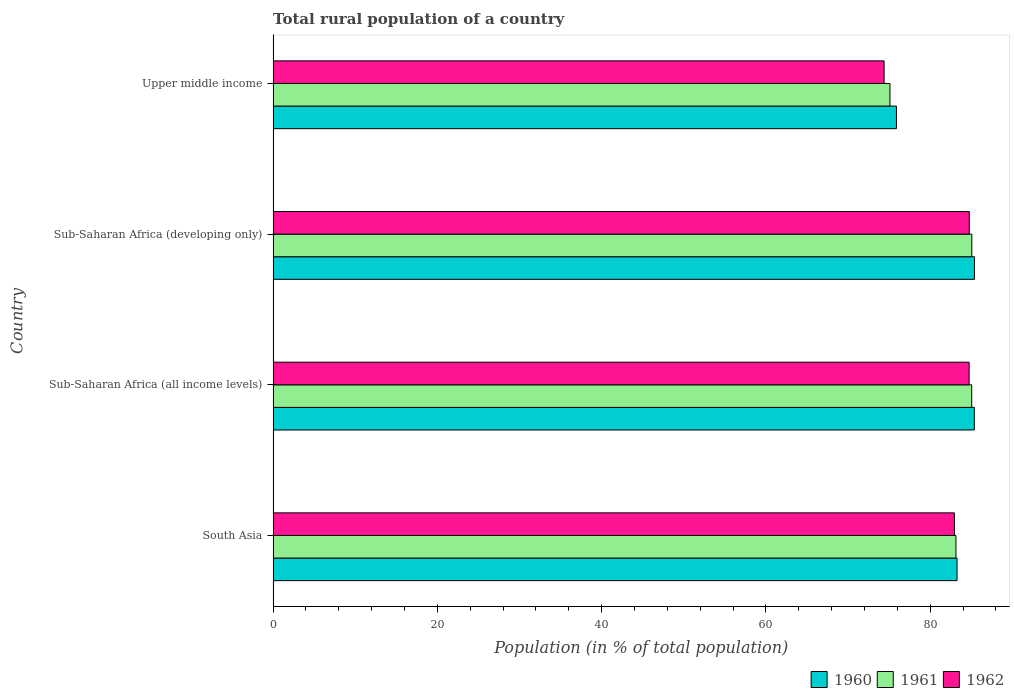How many groups of bars are there?
Offer a terse response. 4. Are the number of bars per tick equal to the number of legend labels?
Give a very brief answer. Yes. How many bars are there on the 1st tick from the top?
Your response must be concise. 3. What is the label of the 3rd group of bars from the top?
Give a very brief answer. Sub-Saharan Africa (all income levels). In how many cases, is the number of bars for a given country not equal to the number of legend labels?
Offer a terse response. 0. What is the rural population in 1961 in Upper middle income?
Offer a very short reply. 75.1. Across all countries, what is the maximum rural population in 1962?
Provide a short and direct response. 84.75. Across all countries, what is the minimum rural population in 1961?
Offer a terse response. 75.1. In which country was the rural population in 1961 maximum?
Offer a very short reply. Sub-Saharan Africa (developing only). In which country was the rural population in 1961 minimum?
Provide a short and direct response. Upper middle income. What is the total rural population in 1961 in the graph?
Offer a terse response. 328.35. What is the difference between the rural population in 1962 in Sub-Saharan Africa (all income levels) and that in Sub-Saharan Africa (developing only)?
Your answer should be compact. -0.01. What is the difference between the rural population in 1962 in Upper middle income and the rural population in 1960 in South Asia?
Offer a very short reply. -8.88. What is the average rural population in 1960 per country?
Your answer should be very brief. 82.48. What is the difference between the rural population in 1961 and rural population in 1960 in Sub-Saharan Africa (developing only)?
Your answer should be compact. -0.32. In how many countries, is the rural population in 1962 greater than 72 %?
Provide a short and direct response. 4. What is the ratio of the rural population in 1961 in South Asia to that in Sub-Saharan Africa (all income levels)?
Make the answer very short. 0.98. Is the rural population in 1962 in Sub-Saharan Africa (developing only) less than that in Upper middle income?
Provide a succinct answer. No. What is the difference between the highest and the second highest rural population in 1962?
Make the answer very short. 0.01. What is the difference between the highest and the lowest rural population in 1962?
Ensure brevity in your answer.  10.37. In how many countries, is the rural population in 1960 greater than the average rural population in 1960 taken over all countries?
Ensure brevity in your answer.  3. What does the 2nd bar from the top in Sub-Saharan Africa (all income levels) represents?
Your answer should be very brief. 1961. Is it the case that in every country, the sum of the rural population in 1961 and rural population in 1960 is greater than the rural population in 1962?
Your answer should be compact. Yes. What is the difference between two consecutive major ticks on the X-axis?
Ensure brevity in your answer.  20. Are the values on the major ticks of X-axis written in scientific E-notation?
Keep it short and to the point. No. Does the graph contain any zero values?
Make the answer very short. No. Does the graph contain grids?
Give a very brief answer. No. How many legend labels are there?
Ensure brevity in your answer.  3. What is the title of the graph?
Ensure brevity in your answer.  Total rural population of a country. Does "1978" appear as one of the legend labels in the graph?
Give a very brief answer. No. What is the label or title of the X-axis?
Give a very brief answer. Population (in % of total population). What is the label or title of the Y-axis?
Provide a short and direct response. Country. What is the Population (in % of total population) of 1960 in South Asia?
Your response must be concise. 83.26. What is the Population (in % of total population) of 1961 in South Asia?
Your answer should be very brief. 83.13. What is the Population (in % of total population) in 1962 in South Asia?
Ensure brevity in your answer.  82.95. What is the Population (in % of total population) in 1960 in Sub-Saharan Africa (all income levels)?
Offer a terse response. 85.37. What is the Population (in % of total population) in 1961 in Sub-Saharan Africa (all income levels)?
Your answer should be compact. 85.05. What is the Population (in % of total population) of 1962 in Sub-Saharan Africa (all income levels)?
Offer a very short reply. 84.74. What is the Population (in % of total population) in 1960 in Sub-Saharan Africa (developing only)?
Offer a very short reply. 85.38. What is the Population (in % of total population) in 1961 in Sub-Saharan Africa (developing only)?
Your response must be concise. 85.07. What is the Population (in % of total population) in 1962 in Sub-Saharan Africa (developing only)?
Offer a very short reply. 84.75. What is the Population (in % of total population) in 1960 in Upper middle income?
Your response must be concise. 75.89. What is the Population (in % of total population) in 1961 in Upper middle income?
Your answer should be compact. 75.1. What is the Population (in % of total population) in 1962 in Upper middle income?
Provide a short and direct response. 74.39. Across all countries, what is the maximum Population (in % of total population) in 1960?
Keep it short and to the point. 85.38. Across all countries, what is the maximum Population (in % of total population) of 1961?
Your answer should be compact. 85.07. Across all countries, what is the maximum Population (in % of total population) of 1962?
Your answer should be compact. 84.75. Across all countries, what is the minimum Population (in % of total population) of 1960?
Your answer should be compact. 75.89. Across all countries, what is the minimum Population (in % of total population) of 1961?
Offer a very short reply. 75.1. Across all countries, what is the minimum Population (in % of total population) of 1962?
Give a very brief answer. 74.39. What is the total Population (in % of total population) of 1960 in the graph?
Offer a very short reply. 329.91. What is the total Population (in % of total population) in 1961 in the graph?
Provide a short and direct response. 328.35. What is the total Population (in % of total population) of 1962 in the graph?
Offer a very short reply. 326.83. What is the difference between the Population (in % of total population) in 1960 in South Asia and that in Sub-Saharan Africa (all income levels)?
Offer a very short reply. -2.1. What is the difference between the Population (in % of total population) in 1961 in South Asia and that in Sub-Saharan Africa (all income levels)?
Your answer should be compact. -1.92. What is the difference between the Population (in % of total population) in 1962 in South Asia and that in Sub-Saharan Africa (all income levels)?
Your answer should be very brief. -1.79. What is the difference between the Population (in % of total population) of 1960 in South Asia and that in Sub-Saharan Africa (developing only)?
Your answer should be compact. -2.12. What is the difference between the Population (in % of total population) of 1961 in South Asia and that in Sub-Saharan Africa (developing only)?
Make the answer very short. -1.93. What is the difference between the Population (in % of total population) of 1962 in South Asia and that in Sub-Saharan Africa (developing only)?
Provide a short and direct response. -1.81. What is the difference between the Population (in % of total population) in 1960 in South Asia and that in Upper middle income?
Make the answer very short. 7.37. What is the difference between the Population (in % of total population) of 1961 in South Asia and that in Upper middle income?
Provide a succinct answer. 8.03. What is the difference between the Population (in % of total population) in 1962 in South Asia and that in Upper middle income?
Provide a succinct answer. 8.56. What is the difference between the Population (in % of total population) in 1960 in Sub-Saharan Africa (all income levels) and that in Sub-Saharan Africa (developing only)?
Keep it short and to the point. -0.01. What is the difference between the Population (in % of total population) of 1961 in Sub-Saharan Africa (all income levels) and that in Sub-Saharan Africa (developing only)?
Your response must be concise. -0.01. What is the difference between the Population (in % of total population) of 1962 in Sub-Saharan Africa (all income levels) and that in Sub-Saharan Africa (developing only)?
Ensure brevity in your answer.  -0.01. What is the difference between the Population (in % of total population) of 1960 in Sub-Saharan Africa (all income levels) and that in Upper middle income?
Make the answer very short. 9.48. What is the difference between the Population (in % of total population) in 1961 in Sub-Saharan Africa (all income levels) and that in Upper middle income?
Keep it short and to the point. 9.95. What is the difference between the Population (in % of total population) in 1962 in Sub-Saharan Africa (all income levels) and that in Upper middle income?
Give a very brief answer. 10.35. What is the difference between the Population (in % of total population) of 1960 in Sub-Saharan Africa (developing only) and that in Upper middle income?
Give a very brief answer. 9.49. What is the difference between the Population (in % of total population) in 1961 in Sub-Saharan Africa (developing only) and that in Upper middle income?
Offer a very short reply. 9.97. What is the difference between the Population (in % of total population) of 1962 in Sub-Saharan Africa (developing only) and that in Upper middle income?
Offer a terse response. 10.37. What is the difference between the Population (in % of total population) of 1960 in South Asia and the Population (in % of total population) of 1961 in Sub-Saharan Africa (all income levels)?
Give a very brief answer. -1.79. What is the difference between the Population (in % of total population) of 1960 in South Asia and the Population (in % of total population) of 1962 in Sub-Saharan Africa (all income levels)?
Keep it short and to the point. -1.48. What is the difference between the Population (in % of total population) of 1961 in South Asia and the Population (in % of total population) of 1962 in Sub-Saharan Africa (all income levels)?
Give a very brief answer. -1.61. What is the difference between the Population (in % of total population) of 1960 in South Asia and the Population (in % of total population) of 1961 in Sub-Saharan Africa (developing only)?
Your answer should be compact. -1.8. What is the difference between the Population (in % of total population) of 1960 in South Asia and the Population (in % of total population) of 1962 in Sub-Saharan Africa (developing only)?
Make the answer very short. -1.49. What is the difference between the Population (in % of total population) of 1961 in South Asia and the Population (in % of total population) of 1962 in Sub-Saharan Africa (developing only)?
Provide a short and direct response. -1.62. What is the difference between the Population (in % of total population) in 1960 in South Asia and the Population (in % of total population) in 1961 in Upper middle income?
Provide a succinct answer. 8.16. What is the difference between the Population (in % of total population) in 1960 in South Asia and the Population (in % of total population) in 1962 in Upper middle income?
Give a very brief answer. 8.88. What is the difference between the Population (in % of total population) in 1961 in South Asia and the Population (in % of total population) in 1962 in Upper middle income?
Offer a terse response. 8.75. What is the difference between the Population (in % of total population) of 1960 in Sub-Saharan Africa (all income levels) and the Population (in % of total population) of 1961 in Sub-Saharan Africa (developing only)?
Make the answer very short. 0.3. What is the difference between the Population (in % of total population) of 1960 in Sub-Saharan Africa (all income levels) and the Population (in % of total population) of 1962 in Sub-Saharan Africa (developing only)?
Offer a terse response. 0.61. What is the difference between the Population (in % of total population) of 1961 in Sub-Saharan Africa (all income levels) and the Population (in % of total population) of 1962 in Sub-Saharan Africa (developing only)?
Your answer should be very brief. 0.3. What is the difference between the Population (in % of total population) in 1960 in Sub-Saharan Africa (all income levels) and the Population (in % of total population) in 1961 in Upper middle income?
Keep it short and to the point. 10.27. What is the difference between the Population (in % of total population) of 1960 in Sub-Saharan Africa (all income levels) and the Population (in % of total population) of 1962 in Upper middle income?
Make the answer very short. 10.98. What is the difference between the Population (in % of total population) of 1961 in Sub-Saharan Africa (all income levels) and the Population (in % of total population) of 1962 in Upper middle income?
Keep it short and to the point. 10.67. What is the difference between the Population (in % of total population) in 1960 in Sub-Saharan Africa (developing only) and the Population (in % of total population) in 1961 in Upper middle income?
Provide a short and direct response. 10.28. What is the difference between the Population (in % of total population) of 1960 in Sub-Saharan Africa (developing only) and the Population (in % of total population) of 1962 in Upper middle income?
Offer a terse response. 11. What is the difference between the Population (in % of total population) of 1961 in Sub-Saharan Africa (developing only) and the Population (in % of total population) of 1962 in Upper middle income?
Offer a very short reply. 10.68. What is the average Population (in % of total population) of 1960 per country?
Provide a succinct answer. 82.48. What is the average Population (in % of total population) in 1961 per country?
Your response must be concise. 82.09. What is the average Population (in % of total population) in 1962 per country?
Offer a terse response. 81.71. What is the difference between the Population (in % of total population) in 1960 and Population (in % of total population) in 1961 in South Asia?
Your answer should be very brief. 0.13. What is the difference between the Population (in % of total population) of 1960 and Population (in % of total population) of 1962 in South Asia?
Provide a succinct answer. 0.32. What is the difference between the Population (in % of total population) in 1961 and Population (in % of total population) in 1962 in South Asia?
Your response must be concise. 0.19. What is the difference between the Population (in % of total population) of 1960 and Population (in % of total population) of 1961 in Sub-Saharan Africa (all income levels)?
Your answer should be very brief. 0.32. What is the difference between the Population (in % of total population) in 1960 and Population (in % of total population) in 1962 in Sub-Saharan Africa (all income levels)?
Make the answer very short. 0.63. What is the difference between the Population (in % of total population) in 1961 and Population (in % of total population) in 1962 in Sub-Saharan Africa (all income levels)?
Your answer should be compact. 0.31. What is the difference between the Population (in % of total population) of 1960 and Population (in % of total population) of 1961 in Sub-Saharan Africa (developing only)?
Make the answer very short. 0.32. What is the difference between the Population (in % of total population) of 1960 and Population (in % of total population) of 1962 in Sub-Saharan Africa (developing only)?
Offer a very short reply. 0.63. What is the difference between the Population (in % of total population) of 1961 and Population (in % of total population) of 1962 in Sub-Saharan Africa (developing only)?
Ensure brevity in your answer.  0.31. What is the difference between the Population (in % of total population) of 1960 and Population (in % of total population) of 1961 in Upper middle income?
Provide a short and direct response. 0.79. What is the difference between the Population (in % of total population) in 1960 and Population (in % of total population) in 1962 in Upper middle income?
Make the answer very short. 1.5. What is the difference between the Population (in % of total population) of 1961 and Population (in % of total population) of 1962 in Upper middle income?
Provide a succinct answer. 0.71. What is the ratio of the Population (in % of total population) in 1960 in South Asia to that in Sub-Saharan Africa (all income levels)?
Your answer should be very brief. 0.98. What is the ratio of the Population (in % of total population) in 1961 in South Asia to that in Sub-Saharan Africa (all income levels)?
Your answer should be very brief. 0.98. What is the ratio of the Population (in % of total population) in 1962 in South Asia to that in Sub-Saharan Africa (all income levels)?
Offer a very short reply. 0.98. What is the ratio of the Population (in % of total population) of 1960 in South Asia to that in Sub-Saharan Africa (developing only)?
Your answer should be compact. 0.98. What is the ratio of the Population (in % of total population) in 1961 in South Asia to that in Sub-Saharan Africa (developing only)?
Keep it short and to the point. 0.98. What is the ratio of the Population (in % of total population) in 1962 in South Asia to that in Sub-Saharan Africa (developing only)?
Your response must be concise. 0.98. What is the ratio of the Population (in % of total population) in 1960 in South Asia to that in Upper middle income?
Your answer should be very brief. 1.1. What is the ratio of the Population (in % of total population) in 1961 in South Asia to that in Upper middle income?
Offer a very short reply. 1.11. What is the ratio of the Population (in % of total population) of 1962 in South Asia to that in Upper middle income?
Ensure brevity in your answer.  1.11. What is the ratio of the Population (in % of total population) of 1960 in Sub-Saharan Africa (all income levels) to that in Upper middle income?
Your answer should be very brief. 1.12. What is the ratio of the Population (in % of total population) of 1961 in Sub-Saharan Africa (all income levels) to that in Upper middle income?
Your answer should be very brief. 1.13. What is the ratio of the Population (in % of total population) in 1962 in Sub-Saharan Africa (all income levels) to that in Upper middle income?
Give a very brief answer. 1.14. What is the ratio of the Population (in % of total population) in 1960 in Sub-Saharan Africa (developing only) to that in Upper middle income?
Make the answer very short. 1.13. What is the ratio of the Population (in % of total population) of 1961 in Sub-Saharan Africa (developing only) to that in Upper middle income?
Keep it short and to the point. 1.13. What is the ratio of the Population (in % of total population) in 1962 in Sub-Saharan Africa (developing only) to that in Upper middle income?
Offer a very short reply. 1.14. What is the difference between the highest and the second highest Population (in % of total population) of 1960?
Give a very brief answer. 0.01. What is the difference between the highest and the second highest Population (in % of total population) of 1961?
Make the answer very short. 0.01. What is the difference between the highest and the second highest Population (in % of total population) in 1962?
Your response must be concise. 0.01. What is the difference between the highest and the lowest Population (in % of total population) in 1960?
Your answer should be very brief. 9.49. What is the difference between the highest and the lowest Population (in % of total population) in 1961?
Ensure brevity in your answer.  9.97. What is the difference between the highest and the lowest Population (in % of total population) in 1962?
Give a very brief answer. 10.37. 